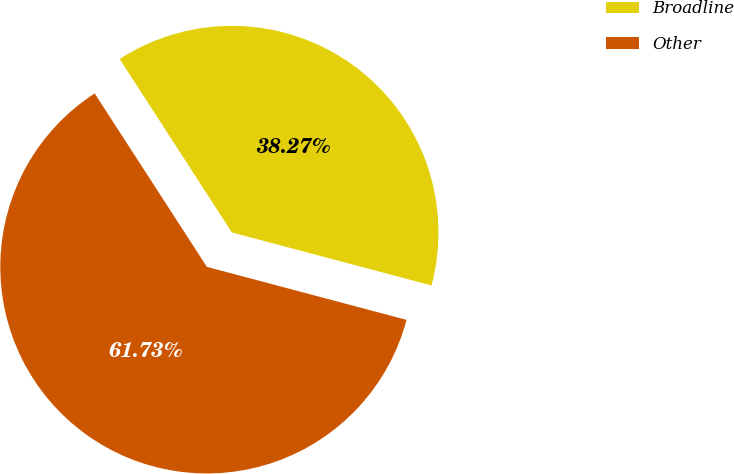Convert chart. <chart><loc_0><loc_0><loc_500><loc_500><pie_chart><fcel>Broadline<fcel>Other<nl><fcel>38.27%<fcel>61.73%<nl></chart> 